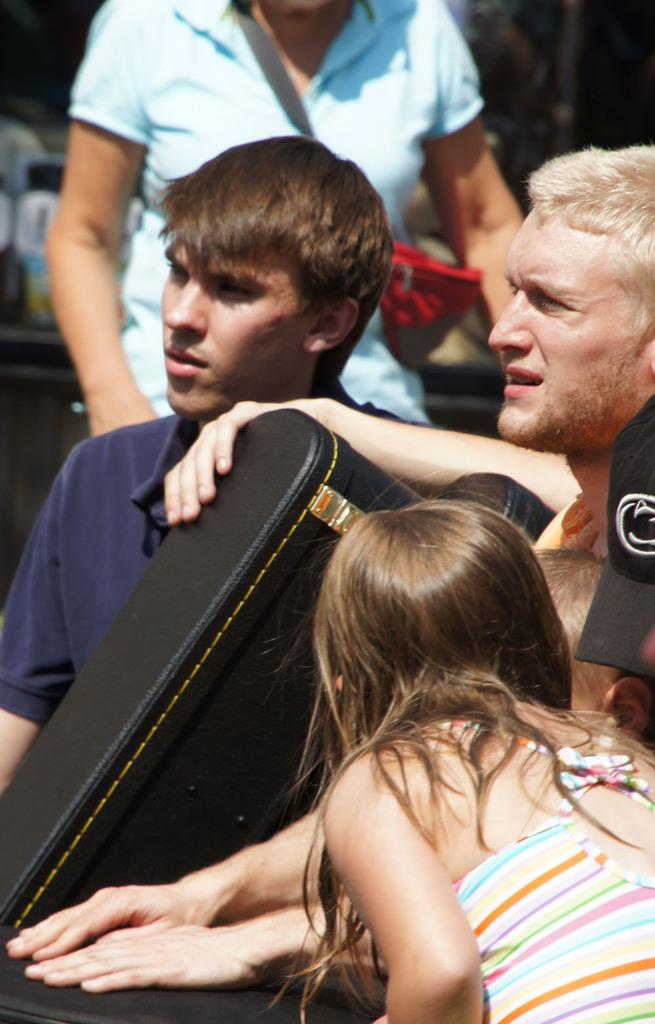How many people are present in the image? There are three people standing in the image. What are the three people holding? The three people are holding a black bag. Can you describe the woman in the background of the image? The woman in the background is wearing a handbag. What type of drink is the woman in the background holding? There is no drink visible in the image; the woman is wearing a handbag. 